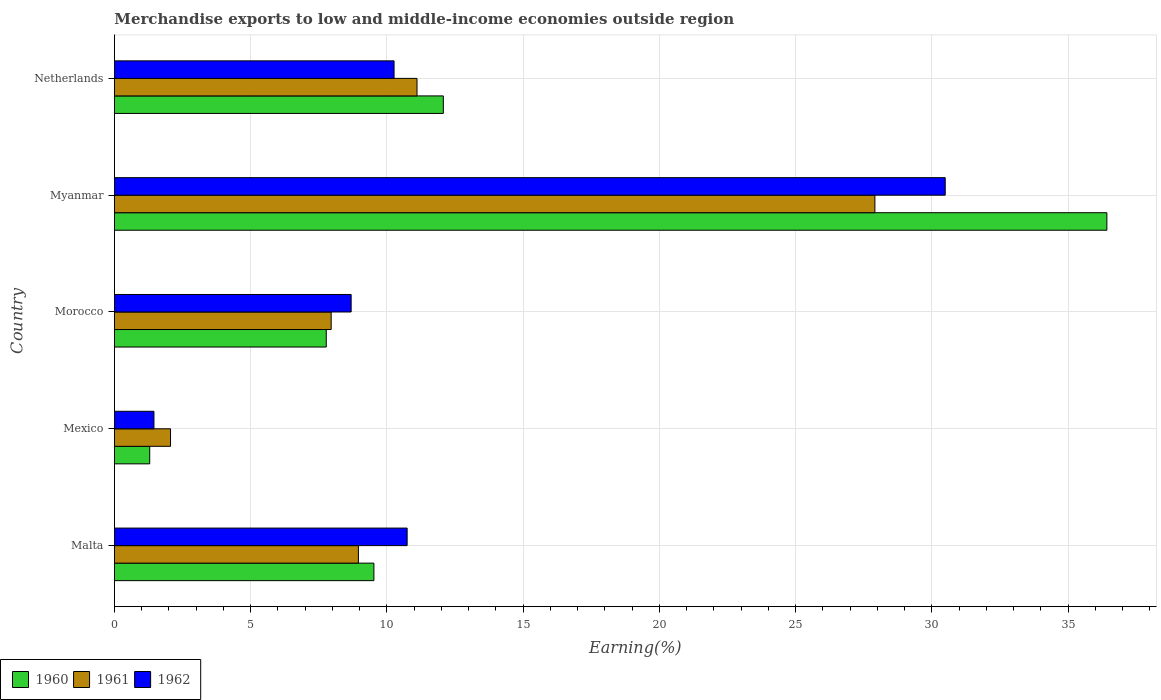How many groups of bars are there?
Keep it short and to the point. 5. Are the number of bars per tick equal to the number of legend labels?
Make the answer very short. Yes. Are the number of bars on each tick of the Y-axis equal?
Make the answer very short. Yes. How many bars are there on the 5th tick from the bottom?
Offer a terse response. 3. What is the label of the 5th group of bars from the top?
Offer a terse response. Malta. In how many cases, is the number of bars for a given country not equal to the number of legend labels?
Keep it short and to the point. 0. What is the percentage of amount earned from merchandise exports in 1962 in Morocco?
Your answer should be very brief. 8.69. Across all countries, what is the maximum percentage of amount earned from merchandise exports in 1960?
Provide a succinct answer. 36.43. Across all countries, what is the minimum percentage of amount earned from merchandise exports in 1962?
Offer a very short reply. 1.45. In which country was the percentage of amount earned from merchandise exports in 1962 maximum?
Make the answer very short. Myanmar. In which country was the percentage of amount earned from merchandise exports in 1962 minimum?
Offer a terse response. Mexico. What is the total percentage of amount earned from merchandise exports in 1962 in the graph?
Ensure brevity in your answer.  61.64. What is the difference between the percentage of amount earned from merchandise exports in 1961 in Malta and that in Mexico?
Your answer should be very brief. 6.9. What is the difference between the percentage of amount earned from merchandise exports in 1960 in Myanmar and the percentage of amount earned from merchandise exports in 1962 in Malta?
Ensure brevity in your answer.  25.68. What is the average percentage of amount earned from merchandise exports in 1962 per country?
Make the answer very short. 12.33. What is the difference between the percentage of amount earned from merchandise exports in 1962 and percentage of amount earned from merchandise exports in 1961 in Myanmar?
Provide a short and direct response. 2.58. What is the ratio of the percentage of amount earned from merchandise exports in 1960 in Mexico to that in Morocco?
Your answer should be compact. 0.17. What is the difference between the highest and the second highest percentage of amount earned from merchandise exports in 1960?
Your answer should be compact. 24.35. What is the difference between the highest and the lowest percentage of amount earned from merchandise exports in 1960?
Offer a very short reply. 35.13. What does the 2nd bar from the top in Netherlands represents?
Provide a succinct answer. 1961. What does the 3rd bar from the bottom in Myanmar represents?
Give a very brief answer. 1962. Are the values on the major ticks of X-axis written in scientific E-notation?
Offer a very short reply. No. Does the graph contain any zero values?
Make the answer very short. No. What is the title of the graph?
Offer a terse response. Merchandise exports to low and middle-income economies outside region. Does "1993" appear as one of the legend labels in the graph?
Your response must be concise. No. What is the label or title of the X-axis?
Provide a short and direct response. Earning(%). What is the Earning(%) of 1960 in Malta?
Your response must be concise. 9.52. What is the Earning(%) of 1961 in Malta?
Provide a short and direct response. 8.96. What is the Earning(%) of 1962 in Malta?
Your answer should be very brief. 10.74. What is the Earning(%) of 1960 in Mexico?
Your answer should be very brief. 1.3. What is the Earning(%) in 1961 in Mexico?
Offer a very short reply. 2.06. What is the Earning(%) in 1962 in Mexico?
Keep it short and to the point. 1.45. What is the Earning(%) of 1960 in Morocco?
Ensure brevity in your answer.  7.78. What is the Earning(%) of 1961 in Morocco?
Offer a very short reply. 7.96. What is the Earning(%) in 1962 in Morocco?
Offer a terse response. 8.69. What is the Earning(%) in 1960 in Myanmar?
Your answer should be compact. 36.43. What is the Earning(%) in 1961 in Myanmar?
Give a very brief answer. 27.91. What is the Earning(%) in 1962 in Myanmar?
Keep it short and to the point. 30.49. What is the Earning(%) of 1960 in Netherlands?
Your answer should be very brief. 12.07. What is the Earning(%) in 1961 in Netherlands?
Offer a terse response. 11.11. What is the Earning(%) in 1962 in Netherlands?
Your answer should be compact. 10.26. Across all countries, what is the maximum Earning(%) in 1960?
Offer a very short reply. 36.43. Across all countries, what is the maximum Earning(%) of 1961?
Ensure brevity in your answer.  27.91. Across all countries, what is the maximum Earning(%) in 1962?
Provide a succinct answer. 30.49. Across all countries, what is the minimum Earning(%) of 1960?
Offer a very short reply. 1.3. Across all countries, what is the minimum Earning(%) of 1961?
Offer a terse response. 2.06. Across all countries, what is the minimum Earning(%) in 1962?
Offer a very short reply. 1.45. What is the total Earning(%) of 1960 in the graph?
Your answer should be very brief. 67.09. What is the total Earning(%) of 1961 in the graph?
Provide a short and direct response. 57.99. What is the total Earning(%) of 1962 in the graph?
Ensure brevity in your answer.  61.64. What is the difference between the Earning(%) in 1960 in Malta and that in Mexico?
Ensure brevity in your answer.  8.23. What is the difference between the Earning(%) in 1961 in Malta and that in Mexico?
Offer a very short reply. 6.9. What is the difference between the Earning(%) in 1962 in Malta and that in Mexico?
Your response must be concise. 9.29. What is the difference between the Earning(%) in 1960 in Malta and that in Morocco?
Make the answer very short. 1.75. What is the difference between the Earning(%) of 1961 in Malta and that in Morocco?
Offer a very short reply. 1. What is the difference between the Earning(%) of 1962 in Malta and that in Morocco?
Provide a succinct answer. 2.06. What is the difference between the Earning(%) of 1960 in Malta and that in Myanmar?
Your response must be concise. -26.9. What is the difference between the Earning(%) in 1961 in Malta and that in Myanmar?
Provide a succinct answer. -18.96. What is the difference between the Earning(%) of 1962 in Malta and that in Myanmar?
Your answer should be very brief. -19.75. What is the difference between the Earning(%) of 1960 in Malta and that in Netherlands?
Give a very brief answer. -2.55. What is the difference between the Earning(%) of 1961 in Malta and that in Netherlands?
Your response must be concise. -2.15. What is the difference between the Earning(%) of 1962 in Malta and that in Netherlands?
Keep it short and to the point. 0.48. What is the difference between the Earning(%) in 1960 in Mexico and that in Morocco?
Offer a terse response. -6.48. What is the difference between the Earning(%) of 1961 in Mexico and that in Morocco?
Provide a succinct answer. -5.9. What is the difference between the Earning(%) in 1962 in Mexico and that in Morocco?
Offer a terse response. -7.24. What is the difference between the Earning(%) in 1960 in Mexico and that in Myanmar?
Provide a short and direct response. -35.13. What is the difference between the Earning(%) of 1961 in Mexico and that in Myanmar?
Your response must be concise. -25.85. What is the difference between the Earning(%) in 1962 in Mexico and that in Myanmar?
Give a very brief answer. -29.04. What is the difference between the Earning(%) in 1960 in Mexico and that in Netherlands?
Ensure brevity in your answer.  -10.78. What is the difference between the Earning(%) in 1961 in Mexico and that in Netherlands?
Make the answer very short. -9.05. What is the difference between the Earning(%) in 1962 in Mexico and that in Netherlands?
Your answer should be compact. -8.81. What is the difference between the Earning(%) in 1960 in Morocco and that in Myanmar?
Your response must be concise. -28.65. What is the difference between the Earning(%) in 1961 in Morocco and that in Myanmar?
Your answer should be very brief. -19.96. What is the difference between the Earning(%) in 1962 in Morocco and that in Myanmar?
Your answer should be compact. -21.81. What is the difference between the Earning(%) of 1960 in Morocco and that in Netherlands?
Give a very brief answer. -4.3. What is the difference between the Earning(%) in 1961 in Morocco and that in Netherlands?
Provide a short and direct response. -3.15. What is the difference between the Earning(%) in 1962 in Morocco and that in Netherlands?
Make the answer very short. -1.58. What is the difference between the Earning(%) in 1960 in Myanmar and that in Netherlands?
Give a very brief answer. 24.35. What is the difference between the Earning(%) of 1961 in Myanmar and that in Netherlands?
Ensure brevity in your answer.  16.81. What is the difference between the Earning(%) of 1962 in Myanmar and that in Netherlands?
Your answer should be very brief. 20.23. What is the difference between the Earning(%) of 1960 in Malta and the Earning(%) of 1961 in Mexico?
Provide a succinct answer. 7.46. What is the difference between the Earning(%) in 1960 in Malta and the Earning(%) in 1962 in Mexico?
Give a very brief answer. 8.07. What is the difference between the Earning(%) of 1961 in Malta and the Earning(%) of 1962 in Mexico?
Provide a succinct answer. 7.5. What is the difference between the Earning(%) in 1960 in Malta and the Earning(%) in 1961 in Morocco?
Offer a terse response. 1.57. What is the difference between the Earning(%) of 1960 in Malta and the Earning(%) of 1962 in Morocco?
Your response must be concise. 0.84. What is the difference between the Earning(%) in 1961 in Malta and the Earning(%) in 1962 in Morocco?
Ensure brevity in your answer.  0.27. What is the difference between the Earning(%) in 1960 in Malta and the Earning(%) in 1961 in Myanmar?
Provide a succinct answer. -18.39. What is the difference between the Earning(%) in 1960 in Malta and the Earning(%) in 1962 in Myanmar?
Your response must be concise. -20.97. What is the difference between the Earning(%) in 1961 in Malta and the Earning(%) in 1962 in Myanmar?
Give a very brief answer. -21.54. What is the difference between the Earning(%) in 1960 in Malta and the Earning(%) in 1961 in Netherlands?
Ensure brevity in your answer.  -1.58. What is the difference between the Earning(%) of 1960 in Malta and the Earning(%) of 1962 in Netherlands?
Your response must be concise. -0.74. What is the difference between the Earning(%) in 1961 in Malta and the Earning(%) in 1962 in Netherlands?
Your response must be concise. -1.31. What is the difference between the Earning(%) of 1960 in Mexico and the Earning(%) of 1961 in Morocco?
Offer a very short reply. -6.66. What is the difference between the Earning(%) of 1960 in Mexico and the Earning(%) of 1962 in Morocco?
Your response must be concise. -7.39. What is the difference between the Earning(%) in 1961 in Mexico and the Earning(%) in 1962 in Morocco?
Make the answer very short. -6.63. What is the difference between the Earning(%) of 1960 in Mexico and the Earning(%) of 1961 in Myanmar?
Offer a terse response. -26.62. What is the difference between the Earning(%) of 1960 in Mexico and the Earning(%) of 1962 in Myanmar?
Keep it short and to the point. -29.2. What is the difference between the Earning(%) in 1961 in Mexico and the Earning(%) in 1962 in Myanmar?
Keep it short and to the point. -28.43. What is the difference between the Earning(%) in 1960 in Mexico and the Earning(%) in 1961 in Netherlands?
Make the answer very short. -9.81. What is the difference between the Earning(%) of 1960 in Mexico and the Earning(%) of 1962 in Netherlands?
Ensure brevity in your answer.  -8.97. What is the difference between the Earning(%) of 1961 in Mexico and the Earning(%) of 1962 in Netherlands?
Your answer should be very brief. -8.2. What is the difference between the Earning(%) in 1960 in Morocco and the Earning(%) in 1961 in Myanmar?
Your answer should be very brief. -20.14. What is the difference between the Earning(%) of 1960 in Morocco and the Earning(%) of 1962 in Myanmar?
Your response must be concise. -22.72. What is the difference between the Earning(%) of 1961 in Morocco and the Earning(%) of 1962 in Myanmar?
Give a very brief answer. -22.54. What is the difference between the Earning(%) of 1960 in Morocco and the Earning(%) of 1961 in Netherlands?
Make the answer very short. -3.33. What is the difference between the Earning(%) of 1960 in Morocco and the Earning(%) of 1962 in Netherlands?
Provide a succinct answer. -2.49. What is the difference between the Earning(%) in 1961 in Morocco and the Earning(%) in 1962 in Netherlands?
Your response must be concise. -2.31. What is the difference between the Earning(%) of 1960 in Myanmar and the Earning(%) of 1961 in Netherlands?
Offer a very short reply. 25.32. What is the difference between the Earning(%) of 1960 in Myanmar and the Earning(%) of 1962 in Netherlands?
Your answer should be very brief. 26.16. What is the difference between the Earning(%) in 1961 in Myanmar and the Earning(%) in 1962 in Netherlands?
Provide a succinct answer. 17.65. What is the average Earning(%) of 1960 per country?
Provide a short and direct response. 13.42. What is the average Earning(%) in 1961 per country?
Your answer should be very brief. 11.6. What is the average Earning(%) of 1962 per country?
Provide a short and direct response. 12.33. What is the difference between the Earning(%) of 1960 and Earning(%) of 1961 in Malta?
Provide a short and direct response. 0.57. What is the difference between the Earning(%) in 1960 and Earning(%) in 1962 in Malta?
Make the answer very short. -1.22. What is the difference between the Earning(%) in 1961 and Earning(%) in 1962 in Malta?
Provide a short and direct response. -1.79. What is the difference between the Earning(%) in 1960 and Earning(%) in 1961 in Mexico?
Offer a terse response. -0.76. What is the difference between the Earning(%) of 1960 and Earning(%) of 1962 in Mexico?
Provide a succinct answer. -0.16. What is the difference between the Earning(%) of 1961 and Earning(%) of 1962 in Mexico?
Offer a very short reply. 0.61. What is the difference between the Earning(%) of 1960 and Earning(%) of 1961 in Morocco?
Offer a very short reply. -0.18. What is the difference between the Earning(%) of 1960 and Earning(%) of 1962 in Morocco?
Give a very brief answer. -0.91. What is the difference between the Earning(%) in 1961 and Earning(%) in 1962 in Morocco?
Make the answer very short. -0.73. What is the difference between the Earning(%) of 1960 and Earning(%) of 1961 in Myanmar?
Keep it short and to the point. 8.51. What is the difference between the Earning(%) in 1960 and Earning(%) in 1962 in Myanmar?
Make the answer very short. 5.93. What is the difference between the Earning(%) of 1961 and Earning(%) of 1962 in Myanmar?
Your response must be concise. -2.58. What is the difference between the Earning(%) of 1960 and Earning(%) of 1961 in Netherlands?
Offer a very short reply. 0.97. What is the difference between the Earning(%) of 1960 and Earning(%) of 1962 in Netherlands?
Give a very brief answer. 1.81. What is the difference between the Earning(%) in 1961 and Earning(%) in 1962 in Netherlands?
Make the answer very short. 0.84. What is the ratio of the Earning(%) in 1960 in Malta to that in Mexico?
Give a very brief answer. 7.35. What is the ratio of the Earning(%) of 1961 in Malta to that in Mexico?
Ensure brevity in your answer.  4.35. What is the ratio of the Earning(%) in 1962 in Malta to that in Mexico?
Your answer should be compact. 7.41. What is the ratio of the Earning(%) in 1960 in Malta to that in Morocco?
Your answer should be very brief. 1.22. What is the ratio of the Earning(%) in 1961 in Malta to that in Morocco?
Offer a very short reply. 1.13. What is the ratio of the Earning(%) of 1962 in Malta to that in Morocco?
Ensure brevity in your answer.  1.24. What is the ratio of the Earning(%) in 1960 in Malta to that in Myanmar?
Offer a terse response. 0.26. What is the ratio of the Earning(%) in 1961 in Malta to that in Myanmar?
Keep it short and to the point. 0.32. What is the ratio of the Earning(%) of 1962 in Malta to that in Myanmar?
Your answer should be very brief. 0.35. What is the ratio of the Earning(%) in 1960 in Malta to that in Netherlands?
Keep it short and to the point. 0.79. What is the ratio of the Earning(%) of 1961 in Malta to that in Netherlands?
Your answer should be very brief. 0.81. What is the ratio of the Earning(%) in 1962 in Malta to that in Netherlands?
Give a very brief answer. 1.05. What is the ratio of the Earning(%) in 1960 in Mexico to that in Morocco?
Your answer should be very brief. 0.17. What is the ratio of the Earning(%) of 1961 in Mexico to that in Morocco?
Your answer should be very brief. 0.26. What is the ratio of the Earning(%) of 1962 in Mexico to that in Morocco?
Offer a very short reply. 0.17. What is the ratio of the Earning(%) of 1960 in Mexico to that in Myanmar?
Ensure brevity in your answer.  0.04. What is the ratio of the Earning(%) of 1961 in Mexico to that in Myanmar?
Make the answer very short. 0.07. What is the ratio of the Earning(%) in 1962 in Mexico to that in Myanmar?
Provide a short and direct response. 0.05. What is the ratio of the Earning(%) in 1960 in Mexico to that in Netherlands?
Your response must be concise. 0.11. What is the ratio of the Earning(%) of 1961 in Mexico to that in Netherlands?
Provide a short and direct response. 0.19. What is the ratio of the Earning(%) of 1962 in Mexico to that in Netherlands?
Offer a very short reply. 0.14. What is the ratio of the Earning(%) of 1960 in Morocco to that in Myanmar?
Your answer should be compact. 0.21. What is the ratio of the Earning(%) in 1961 in Morocco to that in Myanmar?
Keep it short and to the point. 0.28. What is the ratio of the Earning(%) of 1962 in Morocco to that in Myanmar?
Provide a succinct answer. 0.28. What is the ratio of the Earning(%) of 1960 in Morocco to that in Netherlands?
Give a very brief answer. 0.64. What is the ratio of the Earning(%) of 1961 in Morocco to that in Netherlands?
Give a very brief answer. 0.72. What is the ratio of the Earning(%) of 1962 in Morocco to that in Netherlands?
Offer a very short reply. 0.85. What is the ratio of the Earning(%) in 1960 in Myanmar to that in Netherlands?
Keep it short and to the point. 3.02. What is the ratio of the Earning(%) in 1961 in Myanmar to that in Netherlands?
Make the answer very short. 2.51. What is the ratio of the Earning(%) of 1962 in Myanmar to that in Netherlands?
Provide a succinct answer. 2.97. What is the difference between the highest and the second highest Earning(%) of 1960?
Your answer should be very brief. 24.35. What is the difference between the highest and the second highest Earning(%) in 1961?
Provide a succinct answer. 16.81. What is the difference between the highest and the second highest Earning(%) of 1962?
Provide a succinct answer. 19.75. What is the difference between the highest and the lowest Earning(%) of 1960?
Make the answer very short. 35.13. What is the difference between the highest and the lowest Earning(%) of 1961?
Provide a succinct answer. 25.85. What is the difference between the highest and the lowest Earning(%) of 1962?
Offer a terse response. 29.04. 